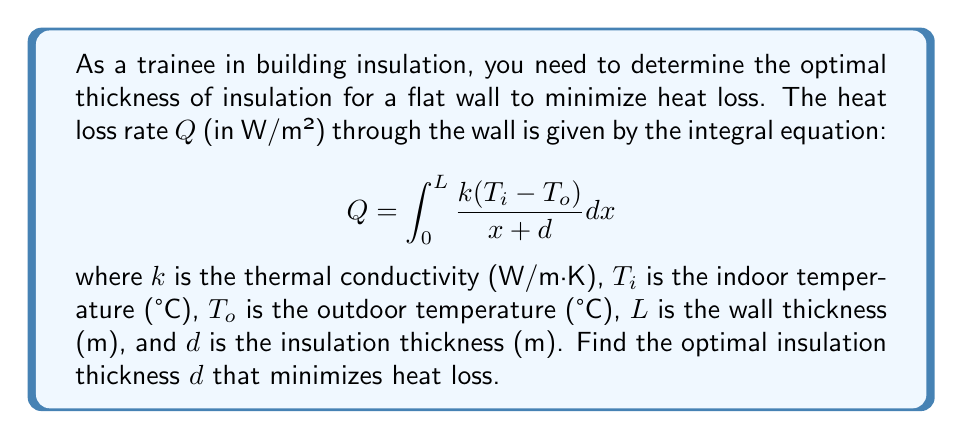What is the answer to this math problem? To find the optimal insulation thickness, we need to follow these steps:

1) First, we need to evaluate the integral:

   $$Q = k(T_i - T_o) \int_0^L \frac{1}{x + d} dx$$

   $$Q = k(T_i - T_o) [\ln(x+d)]_0^L$$

   $$Q = k(T_i - T_o) [\ln(L+d) - \ln(d)]$$

   $$Q = k(T_i - T_o) \ln(\frac{L+d}{d})$$

2) To find the minimum, we differentiate Q with respect to d and set it to zero:

   $$\frac{dQ}{dd} = k(T_i - T_o) \frac{d}{L+d} \cdot \frac{1}{d} - k(T_i - T_o) \frac{1}{d} = 0$$

3) Simplify:

   $$\frac{1}{L+d} - \frac{1}{d} = 0$$

4) Solve for d:

   $$\frac{d}{d(L+d)} = 0$$

   $$d = L+d$$

   $$0 = L$$

5) Since L cannot be zero (as it's the wall thickness), there is no finite value of d that minimizes Q. 

6) However, as d approaches infinity, Q approaches zero:

   $$\lim_{d \to \infty} Q = k(T_i - T_o) \lim_{d \to \infty} \ln(\frac{L+d}{d}) = 0$$

This means that theoretically, the heat loss is minimized as the insulation thickness approaches infinity.
Answer: Optimal thickness: $d \to \infty$ 